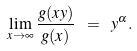Convert formula to latex. <formula><loc_0><loc_0><loc_500><loc_500>\lim _ { x \rightarrow \infty } \frac { g ( x y ) } { g ( x ) } \ = \ y ^ { \alpha } .</formula> 